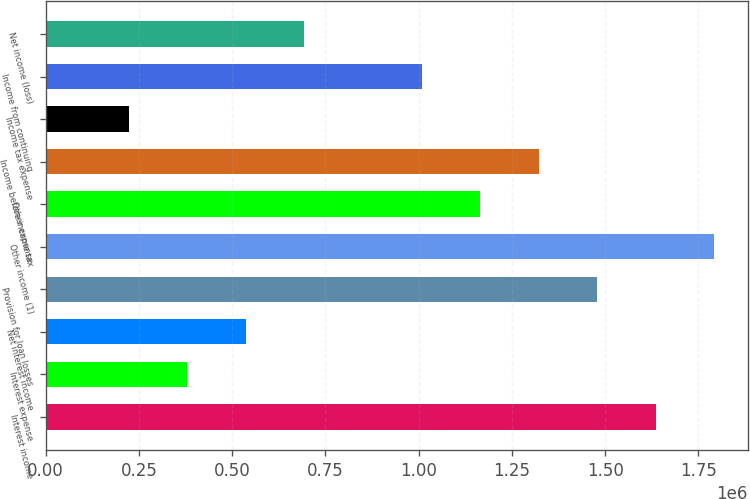Convert chart to OTSL. <chart><loc_0><loc_0><loc_500><loc_500><bar_chart><fcel>Interest income<fcel>Interest expense<fcel>Net interest income<fcel>Provision for loan losses<fcel>Other income (1)<fcel>Other expense<fcel>Income before income tax<fcel>Income tax expense<fcel>Income from continuing<fcel>Net income (loss)<nl><fcel>1.63535e+06<fcel>380226<fcel>537116<fcel>1.47846e+06<fcel>1.79224e+06<fcel>1.16468e+06<fcel>1.32157e+06<fcel>223336<fcel>1.00779e+06<fcel>694006<nl></chart> 